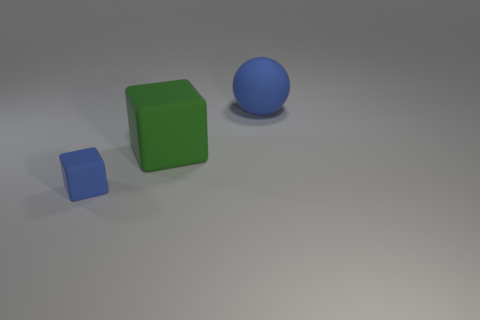Is there any other thing that has the same size as the blue matte block?
Keep it short and to the point. No. Are the big object that is behind the green matte thing and the small block made of the same material?
Keep it short and to the point. Yes. What number of other objects are the same material as the big blue object?
Ensure brevity in your answer.  2. There is another thing that is the same size as the green object; what is its material?
Offer a very short reply. Rubber. There is a green rubber object behind the small blue matte object; is its shape the same as the rubber thing that is to the left of the green block?
Offer a terse response. Yes. What shape is the other thing that is the same size as the green thing?
Offer a terse response. Sphere. Is there a green block that is in front of the blue object on the right side of the big block?
Your answer should be very brief. Yes. What is the color of the tiny thing that is made of the same material as the big cube?
Keep it short and to the point. Blue. Are there more tiny brown cylinders than spheres?
Offer a very short reply. No. What number of objects are either large matte things that are in front of the blue matte ball or big yellow blocks?
Offer a very short reply. 1. 